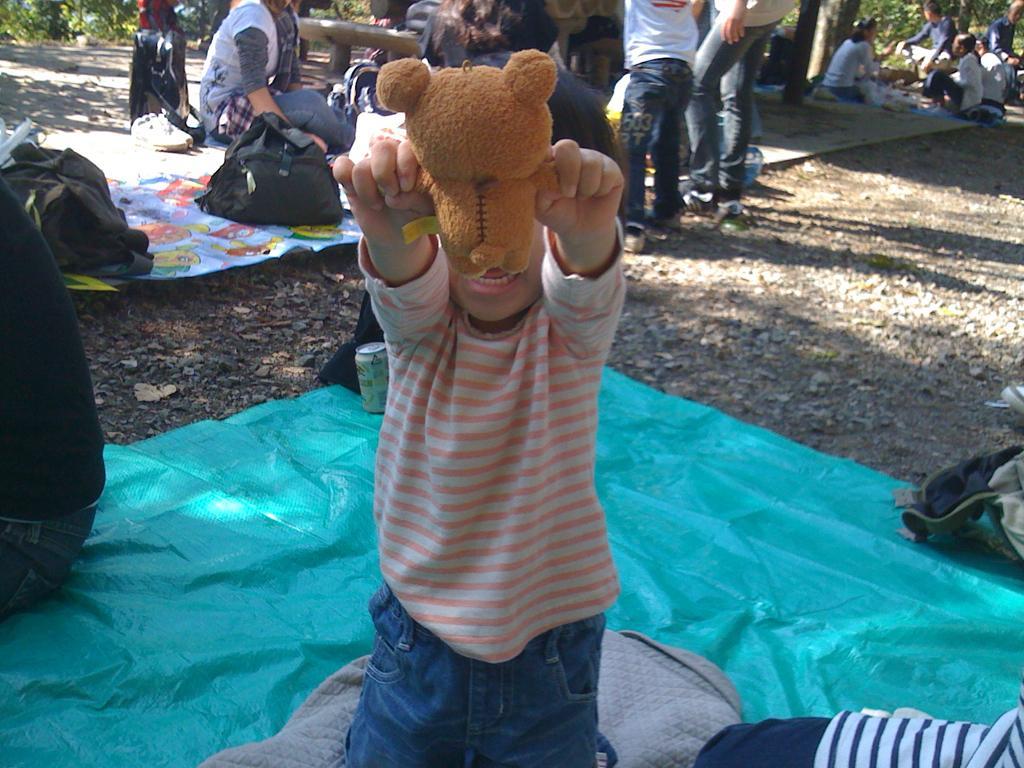How would you summarize this image in a sentence or two? This picture is clicked outside. In the foreground there is a kid, wearing t-shirt, holding a soft toy and seems to be kneeling on an object and we can see the group of persons sitting on the ground and we can see the bags and some other objects are placed on the ground. In the background we can see the group of person standing on the ground and there are some objects in the background and we can see the plants. 